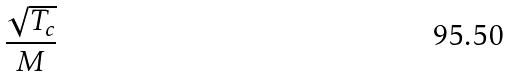<formula> <loc_0><loc_0><loc_500><loc_500>\frac { \sqrt { T _ { c } } } { M }</formula> 